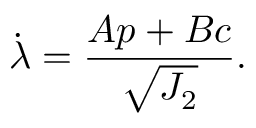Convert formula to latex. <formula><loc_0><loc_0><loc_500><loc_500>\dot { \lambda } = \frac { A p + B c } { \sqrt { J _ { 2 } } } .</formula> 